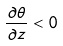Convert formula to latex. <formula><loc_0><loc_0><loc_500><loc_500>\frac { \partial \theta } { \partial z } < 0</formula> 